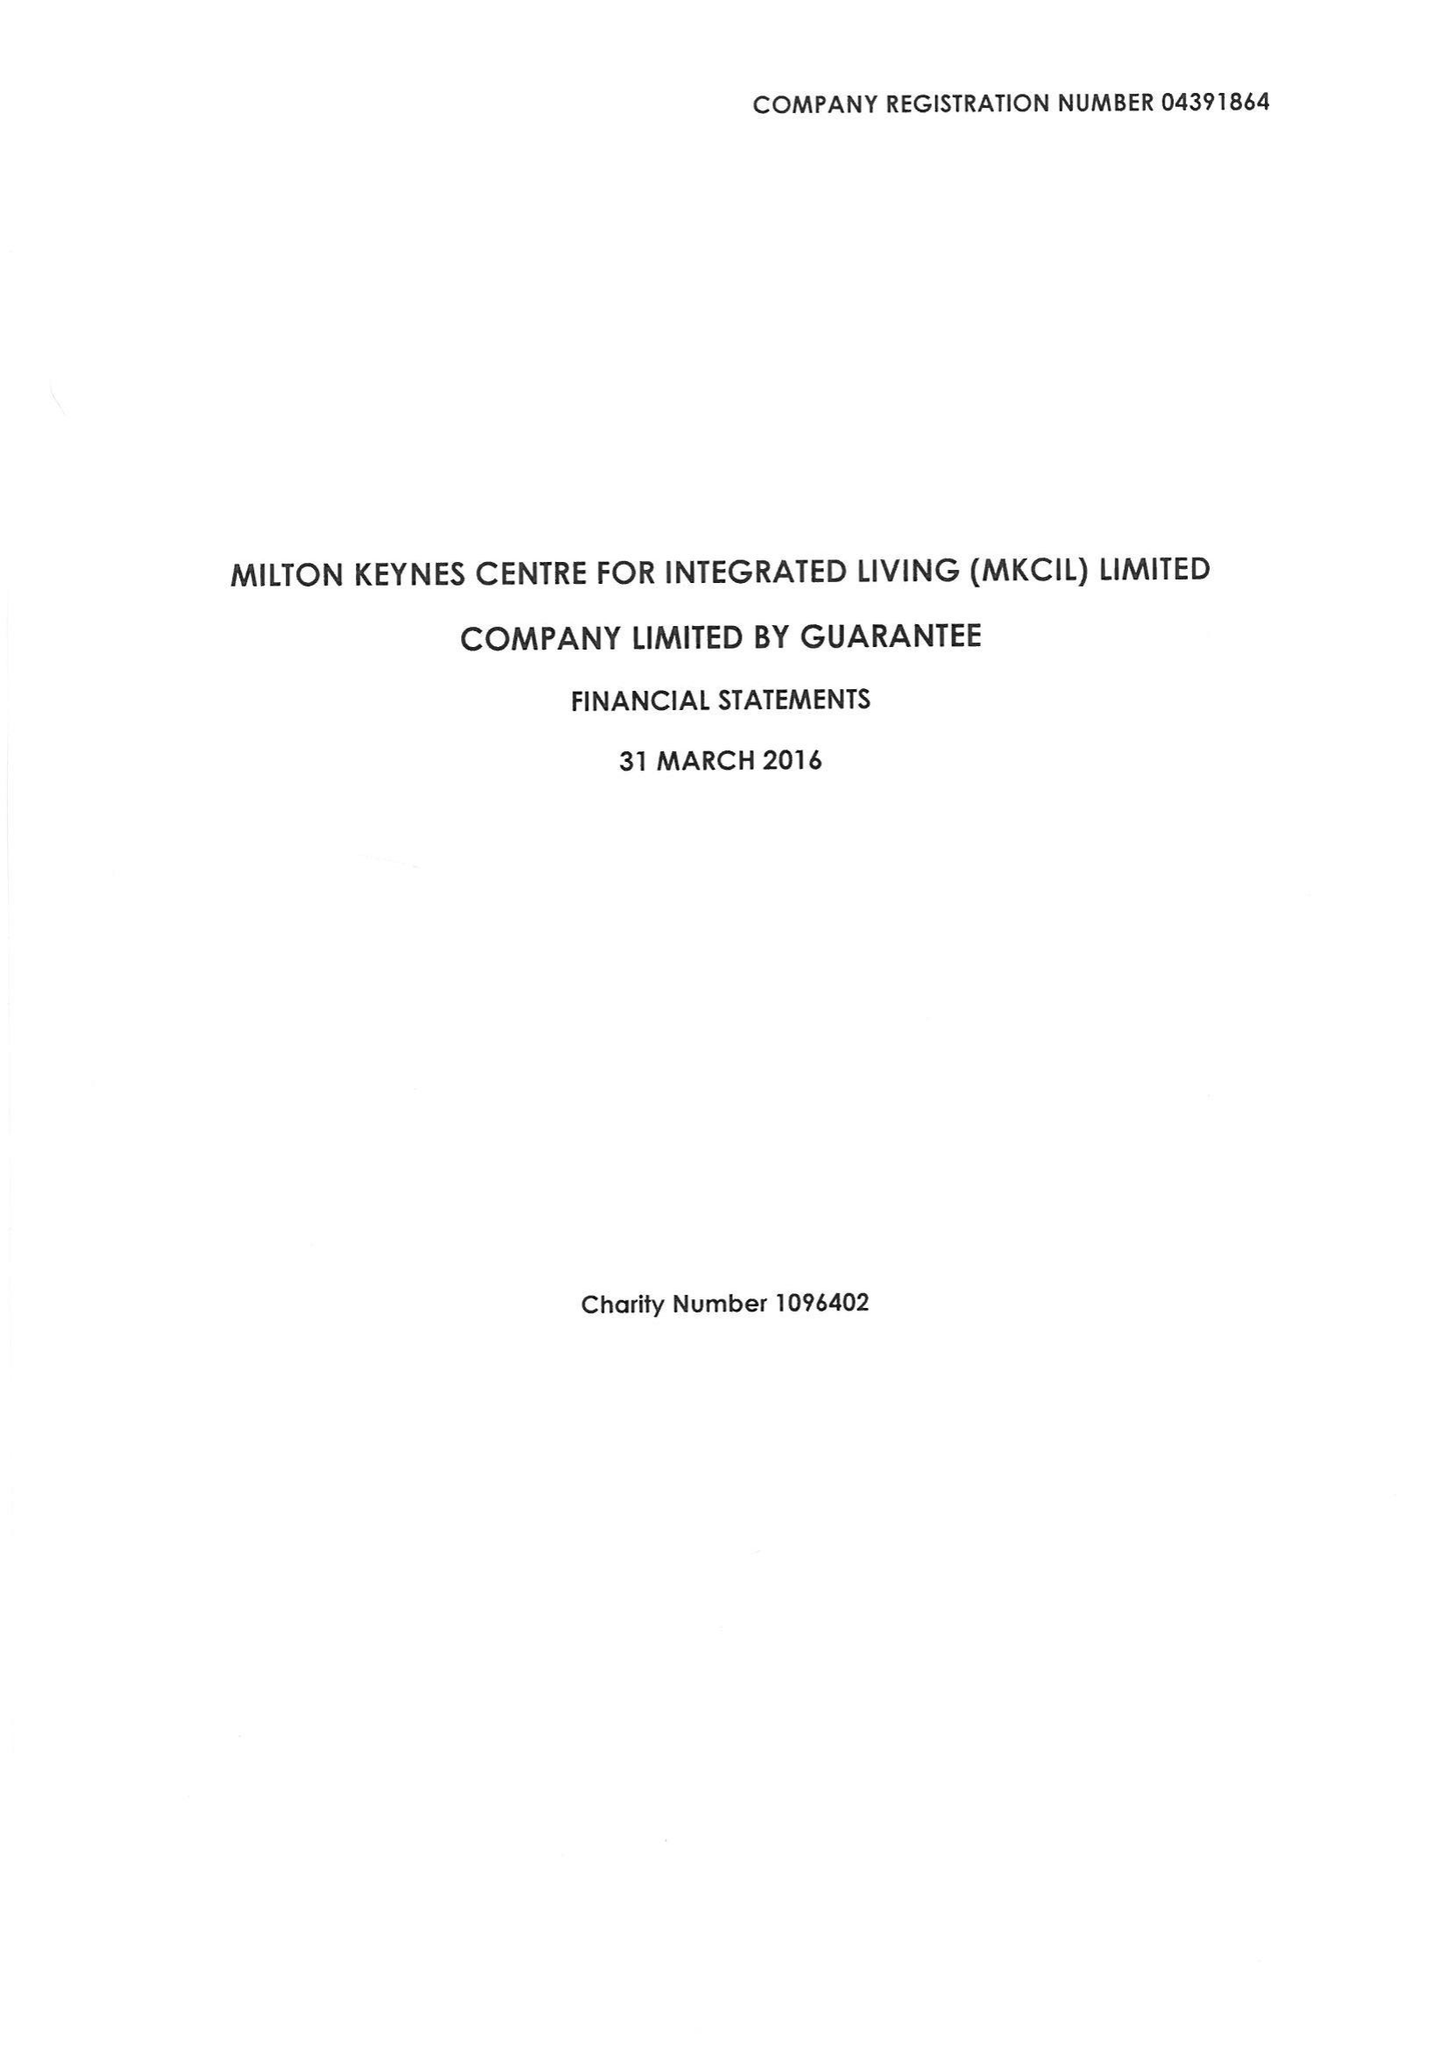What is the value for the charity_name?
Answer the question using a single word or phrase. Milton Keynes Centre For Integrated Living (Mkcil) Ltd. 